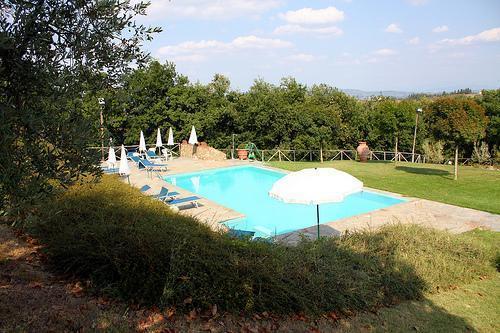How many umbrellas are open?
Give a very brief answer. 1. 